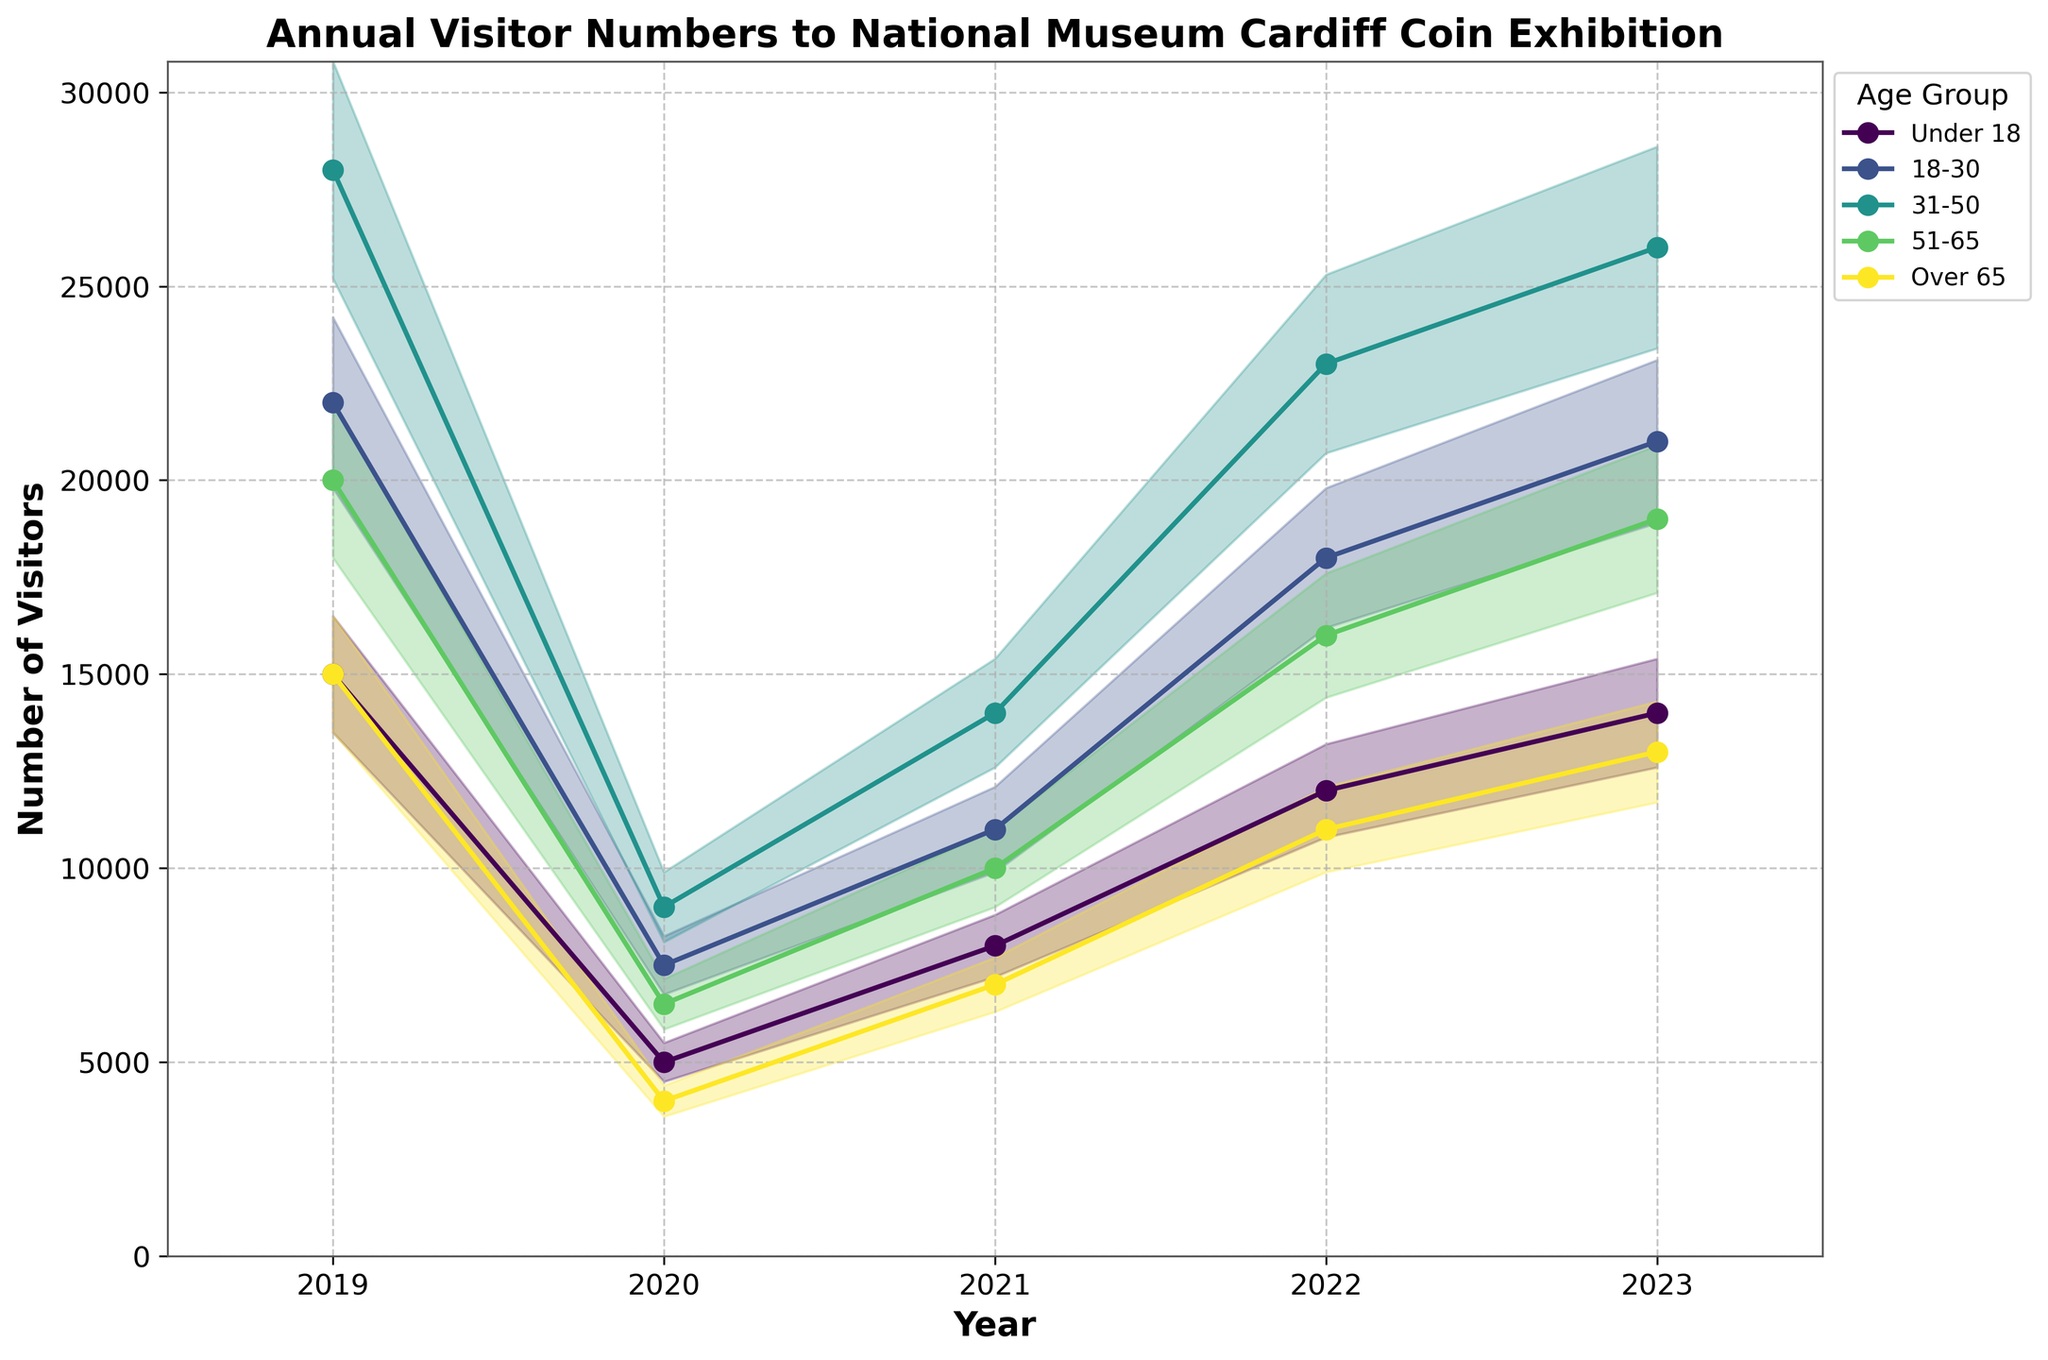What's the title of the chart? The title is located at the top of the chart and provides an overview of what the chart represents.
Answer: Annual Visitor Numbers to National Museum Cardiff Coin Exhibition What was the approximate number of visitors under 18 in 2022? To find this, look at the line corresponding to the 'Under 18' age group and find the data point for the year 2022.
Answer: 12,000 Which age group had the highest number of visitors in 2023? To determine this, compare the data points for all age groups in the year 2023 and identify the maximum value.
Answer: 31-50 How did the visitor numbers for the 'Over 65' age group change from 2019 to 2020? First, find the data points for the 'Over 65' age group in 2019 and 2020. Then, subtract the 2020 value from the 2019 value.
Answer: Decreased by 11,000 What's the average number of visitors in 2023 for the age groups 'Under 18' and '18-30'? First, find the values for 'Under 18' and '18-30' in 2023. Sum these values and then divide by 2. (Under 18: 14,000, 18-30: 21,000)
Answer: 17,500 Which age group showed the most significant increase in visitor numbers from 2020 to 2021? Compare the increase in visitor numbers for each age group between 2020 and 2021. Identify which age group has the highest increment.
Answer: 31-50 What is the total number of visitors to the exhibition in 2023 across all age groups? Sum the visitor numbers for all age groups in the year 2023. (14,000 + 21,000 + 26,000 + 19,000 + 13,000)
Answer: 93,000 Between the years 2021 and 2022, which age group experienced the largest percentage increase in visitor numbers? Calculate the percentage increase for each age group between 2021 and 2022 using the formula ((new value - old value) / old value) * 100. Identify the highest percentage.
Answer: 18-30 How does the trend in visitor numbers for '51-65' compare to the '31-50' group over the years? Observe the lines representing '51-65' and '31-50' over the plotted years 2019 to 2023. Note the differences and similarities in their trends, such as increases, decreases, and relative stability.
Answer: Both groups show a similar overall trend, with a significant decrease in 2020 and a gradual recovery afterwards, but '31-50' consistently has higher numbers 